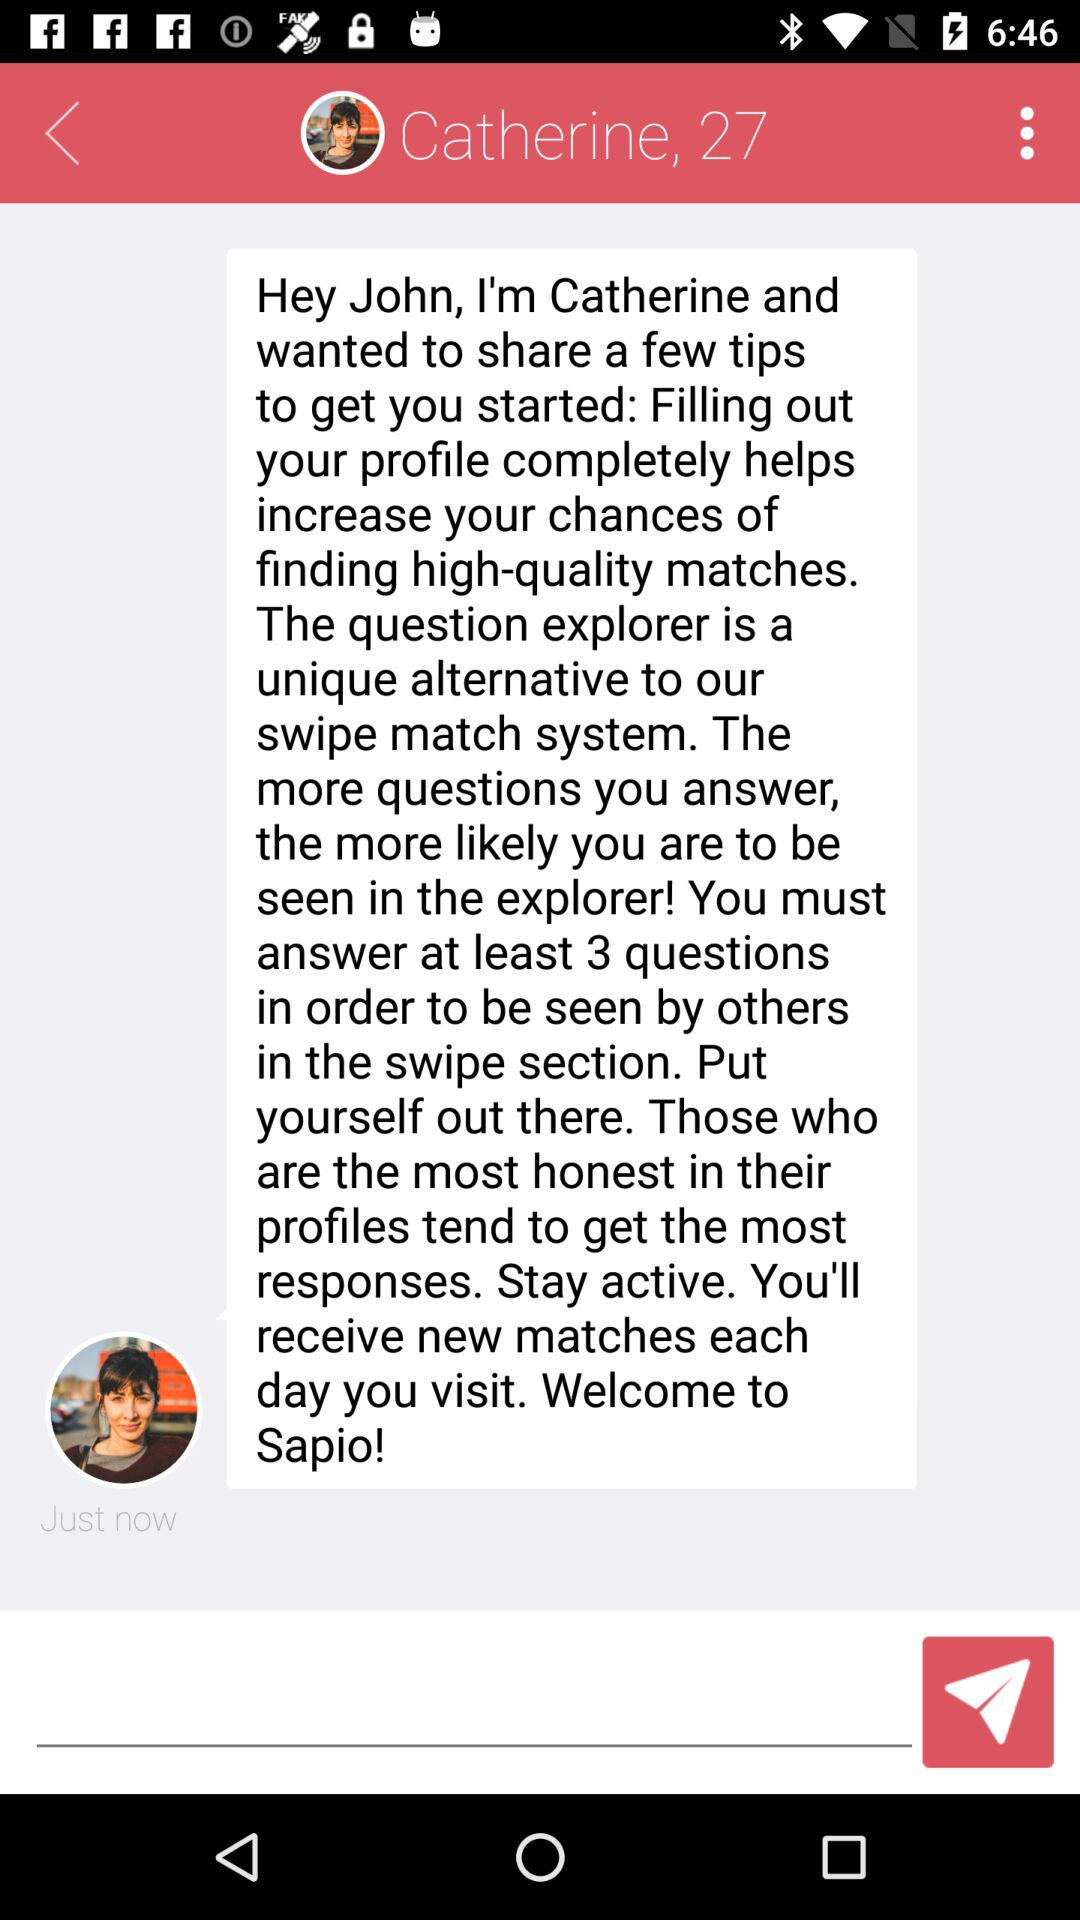How many questions does Catherine say you need to answer in order to be seen by others in the swipe section?
Answer the question using a single word or phrase. 3 